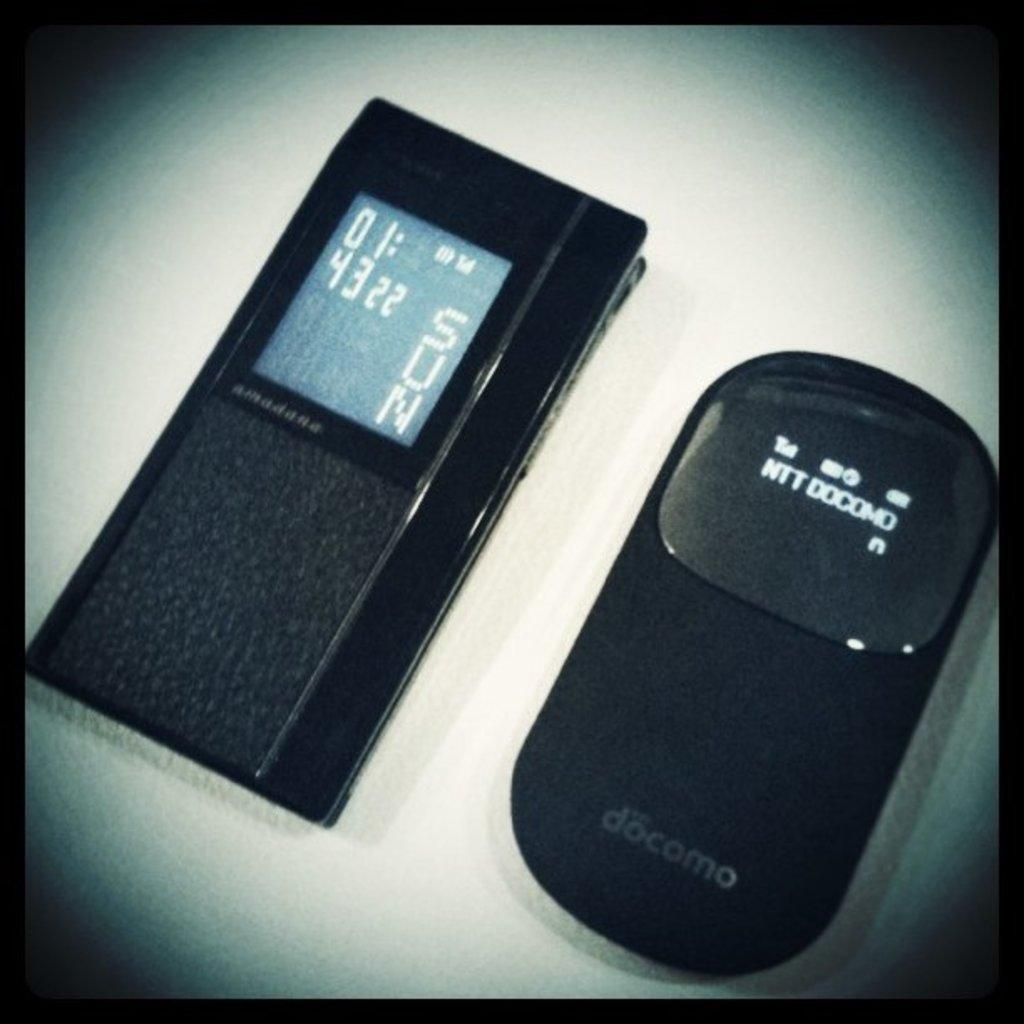<image>
Write a terse but informative summary of the picture. Two electronic devices with one saying it is a sunday and 43 degrees. 